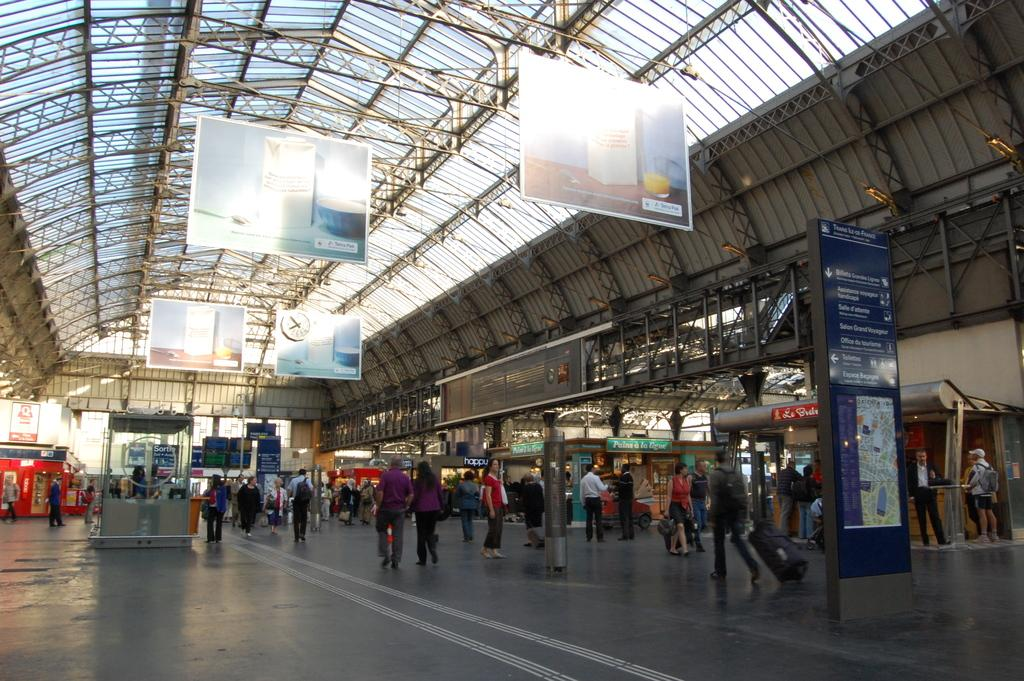How many people can be seen in the image? There are persons in the image, but the exact number is not specified. What architectural features are present in the image? There are pillars in the image. What type of signage is visible in the image? There are advertisements and name boards in the image. What type of establishments can be seen in the image? There are stores in the image. What type of security measures are visible in the image? There are iron bars in the image. What type of informational displays are present in the image? There are charts in the image. What time-keeping device is visible in the image? There is a clock in the image. What type of structure is present in the image? There is a roof in the image. Can you describe the mist surrounding the strangers in the image? There are no strangers or mist present in the image. How does the wave affect the persons in the image? There are no waves present in the image. 